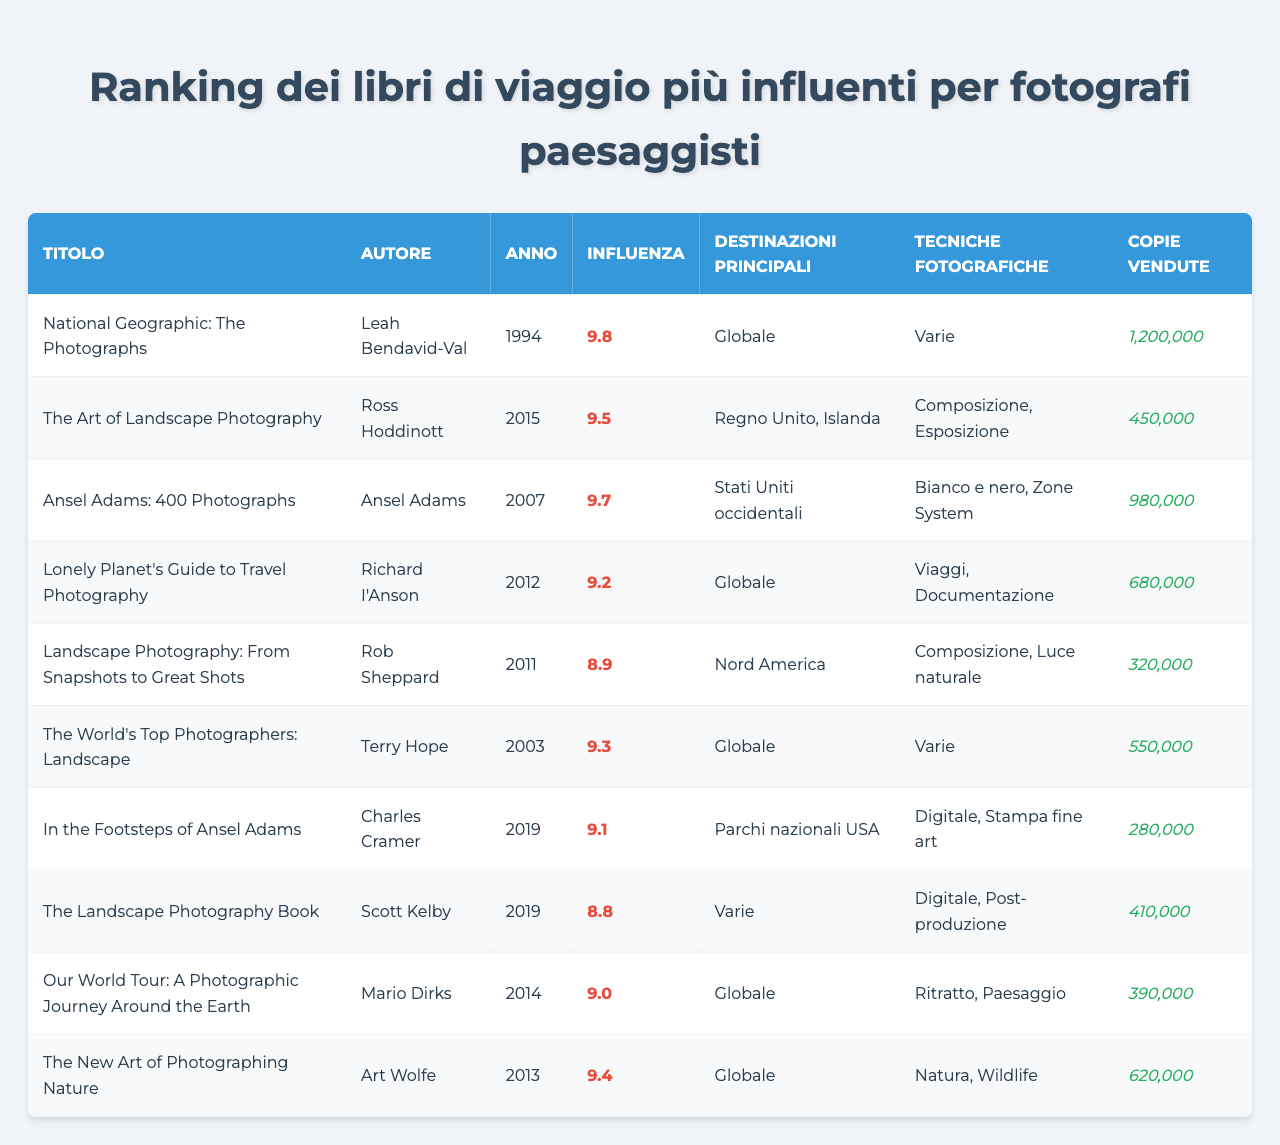Qual è il libro con la maggiore influenza nel ranking? Controllando la colonna "Influenza", il libro con il punteggio più alto è "National Geographic: The Photographs" con un'influenza di 9.8.
Answer: "National Geographic: The Photographs" Qual è l'autore del libro "The Art of Landscape Photography"? Cercando nel campo "Titolo", si trova che "The Art of Landscape Photography" è scritto da Ross Hoddinott.
Answer: Ross Hoddinott Quale libro è stato pubblicato più recentemente? Esaminando la colonna "Anno", l'ultimo libro pubblicato risulta essere "In the Footsteps of Ansel Adams" del 2019.
Answer: "In the Footsteps of Ansel Adams" Quante copie ha venduto "The New Art of Photographing Nature"? Dal campo "Copie vendute", il libro "The New Art of Photographing Nature" ha venduto 620000 copie.
Answer: 620000 Qual è l'influenza media dei libri nella tabella? Si sommano tutti i punteggi di influenza (9.8 + 9.5 + 9.7 + 9.2 + 8.9 + 9.3 + 9.1 + 8.8 + 9.0 + 9.4 =  97.7) e si divide per il numero totale di libri (10), dando così un'influenza media di 9.77.
Answer: 9.77 Quanti libri hanno un'influenza superiore a 9.0? Esaminando la colonna "Influenza", si notano 6 libri con un valore superiore a 9.0: "National Geographic: The Photographs", "Ansel Adams: 400 Photographs", "The Art of Landscape Photography", "The World's Top Photographers: Landscape", "The New Art of Photographing Nature" e "Lonely Planet's Guide to Travel Photography".
Answer: 6 Il libro "Landscape Photography: From Snapshots to Great Shots" vende più copie di "In the Footsteps of Ansel Adams"? Controllando le rispettive vendite, "Landscape Photography: From Snapshots to Great Shots" ha venduto 320000 copie mentre "In the Footsteps of Ansel Adams" ha venduto 280000 copie, quindi sì, vende più copie.
Answer: Sì Qual è il libro che descrive tecniche fotografiche di documentazione? Nella tabella, "Lonely Planet's Guide to Travel Photography" è l'unico libro che specifica tecniche fotografiche di "Viaggi, Documentazione".
Answer: "Lonely Planet's Guide to Travel Photography" Quale tecnica fotografica è menzionata nel libro "Ansel Adams: 400 Photographs"? Dalla colonna "Tecniche fotografiche", emerge che il libro "Ansel Adams: 400 Photographs" menziona "Bianco e nero, Zone System" come tecniche fotografiche.
Answer: Bianco e nero, Zone System Qual è la destinazione principale trattata nel libro "The Landscape Photography Book"? Nella colonna "Destinazioni principali", il libro "The Landscape Photography Book" è indicato come avente "Varie" destinazioni principali.
Answer: Varie 